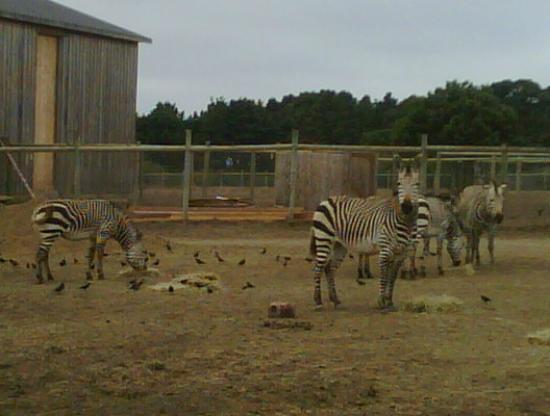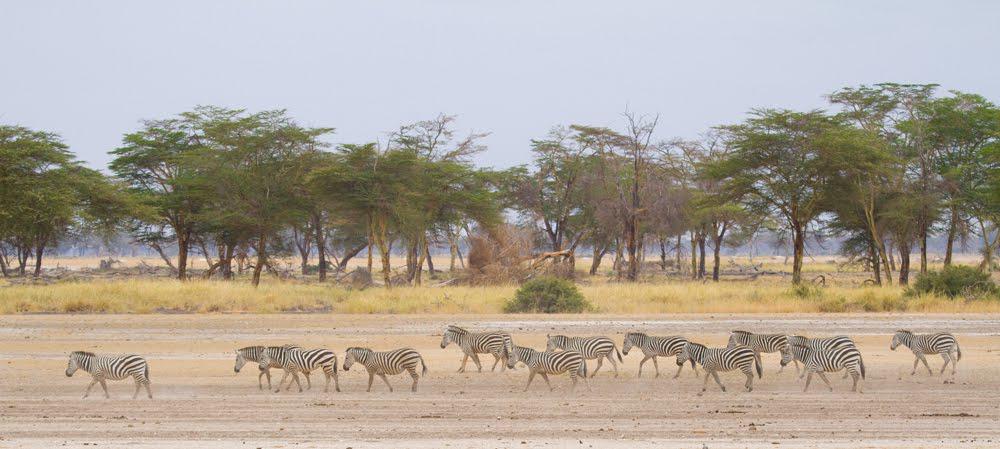The first image is the image on the left, the second image is the image on the right. For the images displayed, is the sentence "The right image contains no more than five zebras." factually correct? Answer yes or no. No. The first image is the image on the left, the second image is the image on the right. Assess this claim about the two images: "There are more than four zebras in each image.". Correct or not? Answer yes or no. Yes. 